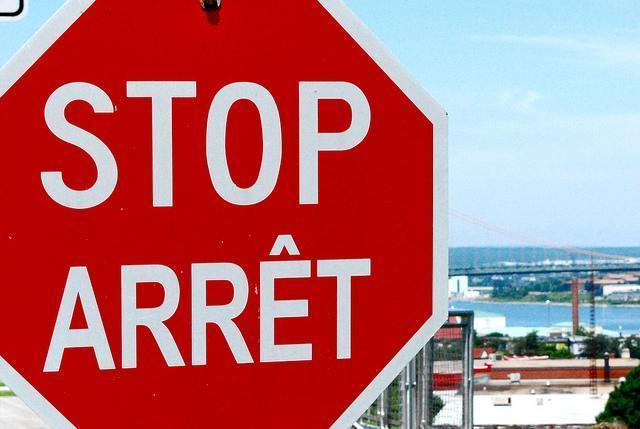How many languages are on the sign?
Give a very brief answer. 2. How many stop signs are in the photo?
Give a very brief answer. 1. How many people are wearing a safety vest in the image?
Give a very brief answer. 0. 